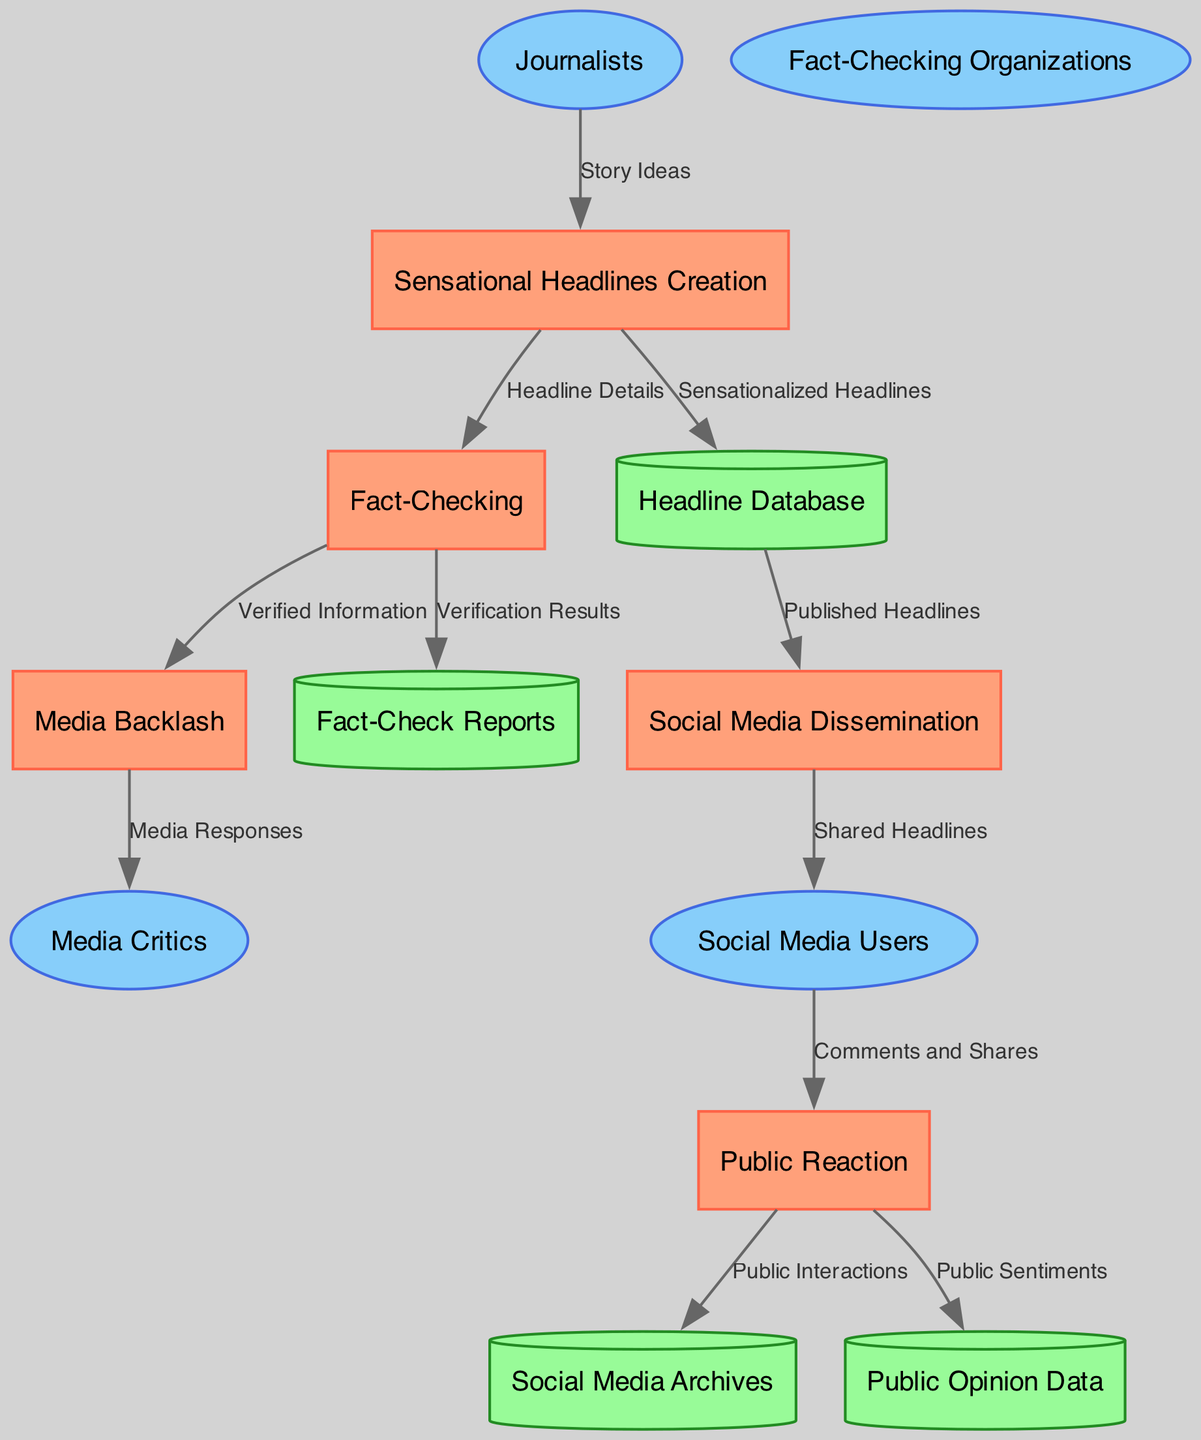What is the name of the process that creates sensational headlines? The process that creates sensational headlines is labeled "Sensational Headlines Creation" in the diagram. This process is explicitly mentioned as the first process in the list of processes.
Answer: Sensational Headlines Creation How many external entities are involved in this data flow diagram? The diagram lists four external entities: Journalists, Social Media Users, Fact-Checking Organizations, and Media Critics. Counting these entities gives a total of four external entities.
Answer: 4 From which external entity do the story ideas flow? According to the data flow, the story ideas flow from the external entity "Journalists" to the process "Sensational Headlines Creation." This directional flow indicates where the information originates.
Answer: Journalists What data is moved from the Fact-Checking to the Media Backlash process? The data that flows from the Fact-Checking process to the Media Backlash process is labeled "Verified Information." This indicates the type of data relevant to the backlash against sensational headlines.
Answer: Verified Information Which data store collects public reactions and sentiments? The data store that collects public reactions and sentiments is called "Public Opinion Data." This storage specifically gathers insights from public responses after headlines are disseminated.
Answer: Public Opinion Data Which process is responsible for verifying information presented in headlines? The process tasked with verifying the information presented in headlines is "Fact-Checking." It ensures the credibility and accuracy of the sensational headlines.
Answer: Fact-Checking What is the output of the Social Media Dissemination process? The output of the Social Media Dissemination process is "Shared Headlines." This represents the headlines that have been disseminated across social media platforms.
Answer: Shared Headlines How many processes are involved in the diagram? The diagram includes five processes: Sensational Headlines Creation, Social Media Dissemination, Public Reaction, Fact-Checking, and Media Backlash. Counting these processes totals five.
Answer: 5 What data flows into the Social Media Archives? The data flowing into the Social Media Archives comes from the Public Reaction process, labeled as "Public Interactions." This indicates the type of data being archived based on public engagement.
Answer: Public Interactions 